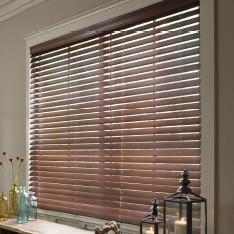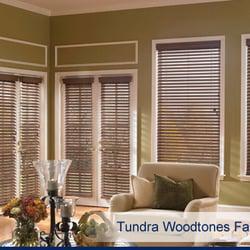The first image is the image on the left, the second image is the image on the right. Given the left and right images, does the statement "At least one couch is sitting in front of the blinds." hold true? Answer yes or no. No. The first image is the image on the left, the second image is the image on the right. Examine the images to the left and right. Is the description "The left and right image contains a total of six blinds on the windows." accurate? Answer yes or no. No. 